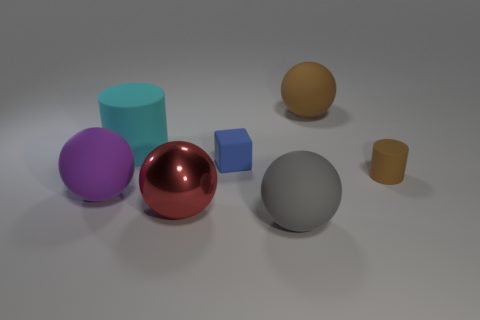Is there a matte sphere that has the same color as the tiny matte cylinder?
Provide a short and direct response. Yes. What size is the ball that is the same color as the tiny cylinder?
Ensure brevity in your answer.  Large. The rubber thing that is the same color as the small matte cylinder is what shape?
Offer a very short reply. Sphere. Are there fewer large rubber objects than large objects?
Provide a succinct answer. Yes. Is there any other thing that has the same color as the metallic thing?
Give a very brief answer. No. What shape is the blue thing right of the big shiny object?
Offer a terse response. Cube. Do the metal ball and the small rubber object that is in front of the tiny block have the same color?
Provide a short and direct response. No. Is the number of cyan objects that are on the right side of the large gray sphere the same as the number of big things that are to the left of the large red thing?
Your answer should be compact. No. How many other objects are the same size as the purple matte ball?
Offer a terse response. 4. The brown cylinder is what size?
Provide a short and direct response. Small. 